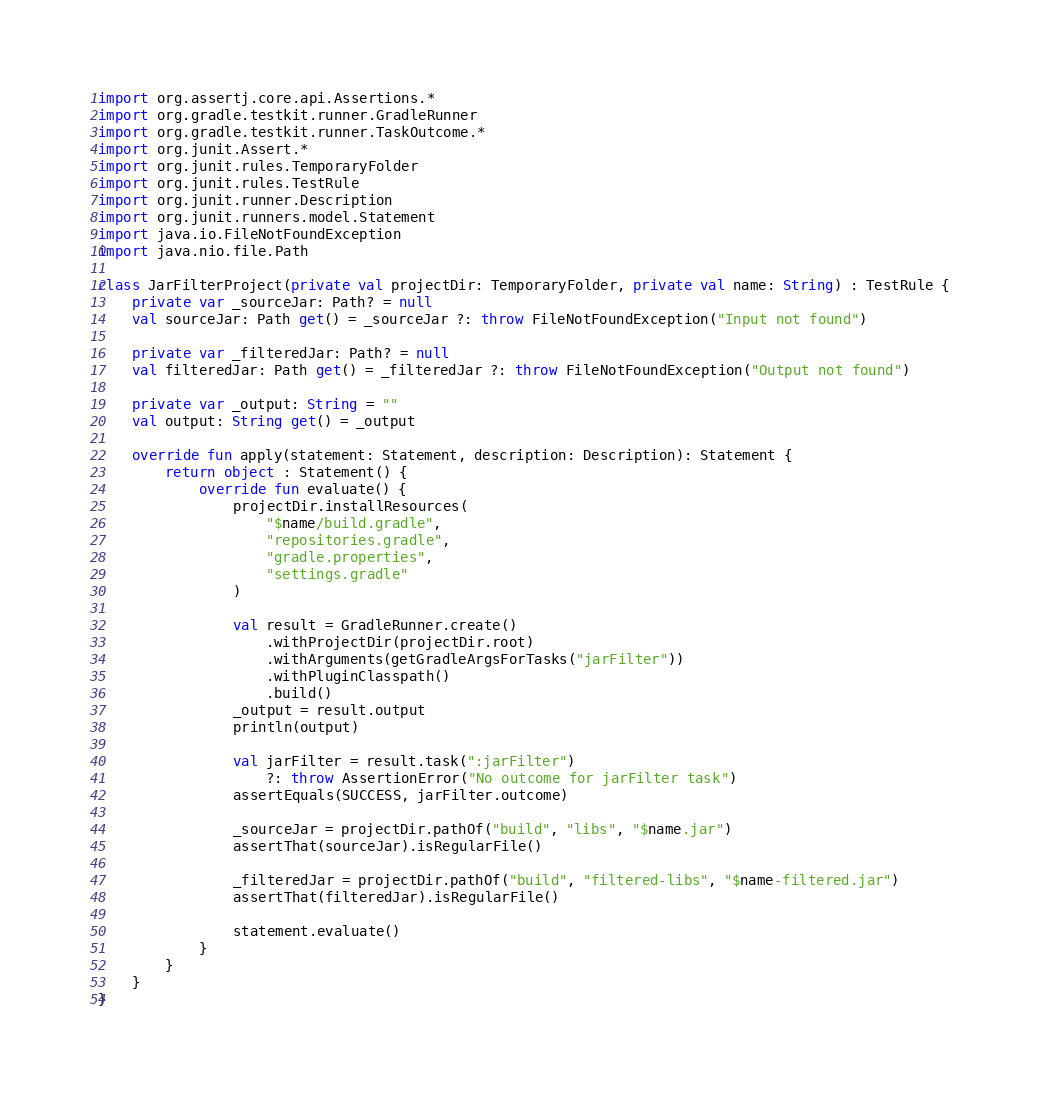Convert code to text. <code><loc_0><loc_0><loc_500><loc_500><_Kotlin_>import org.assertj.core.api.Assertions.*
import org.gradle.testkit.runner.GradleRunner
import org.gradle.testkit.runner.TaskOutcome.*
import org.junit.Assert.*
import org.junit.rules.TemporaryFolder
import org.junit.rules.TestRule
import org.junit.runner.Description
import org.junit.runners.model.Statement
import java.io.FileNotFoundException
import java.nio.file.Path

class JarFilterProject(private val projectDir: TemporaryFolder, private val name: String) : TestRule {
    private var _sourceJar: Path? = null
    val sourceJar: Path get() = _sourceJar ?: throw FileNotFoundException("Input not found")

    private var _filteredJar: Path? = null
    val filteredJar: Path get() = _filteredJar ?: throw FileNotFoundException("Output not found")

    private var _output: String = ""
    val output: String get() = _output

    override fun apply(statement: Statement, description: Description): Statement {
        return object : Statement() {
            override fun evaluate() {
                projectDir.installResources(
                    "$name/build.gradle",
                    "repositories.gradle",
                    "gradle.properties",
                    "settings.gradle"
                )

                val result = GradleRunner.create()
                    .withProjectDir(projectDir.root)
                    .withArguments(getGradleArgsForTasks("jarFilter"))
                    .withPluginClasspath()
                    .build()
                _output = result.output
                println(output)

                val jarFilter = result.task(":jarFilter")
                    ?: throw AssertionError("No outcome for jarFilter task")
                assertEquals(SUCCESS, jarFilter.outcome)

                _sourceJar = projectDir.pathOf("build", "libs", "$name.jar")
                assertThat(sourceJar).isRegularFile()

                _filteredJar = projectDir.pathOf("build", "filtered-libs", "$name-filtered.jar")
                assertThat(filteredJar).isRegularFile()

                statement.evaluate()
            }
        }
    }
}
</code> 